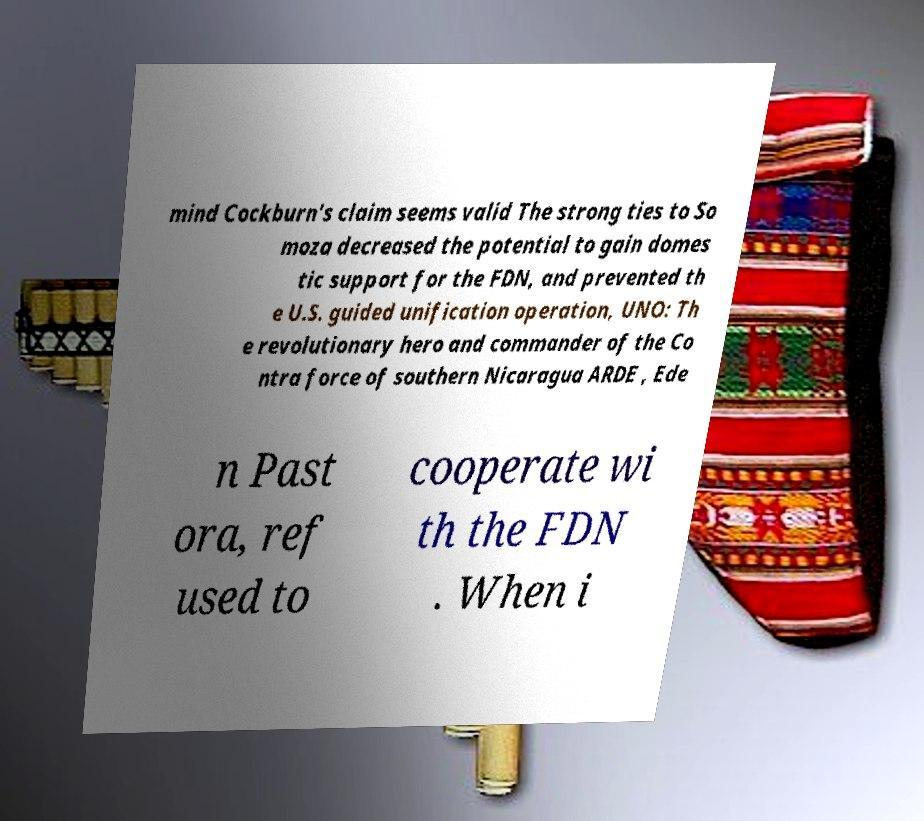Can you read and provide the text displayed in the image?This photo seems to have some interesting text. Can you extract and type it out for me? mind Cockburn's claim seems valid The strong ties to So moza decreased the potential to gain domes tic support for the FDN, and prevented th e U.S. guided unification operation, UNO: Th e revolutionary hero and commander of the Co ntra force of southern Nicaragua ARDE , Ede n Past ora, ref used to cooperate wi th the FDN . When i 